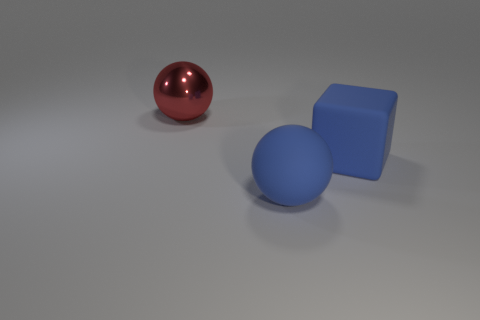How many red metal things are in front of the red sphere that is behind the large blue thing that is to the right of the large matte sphere? 0 